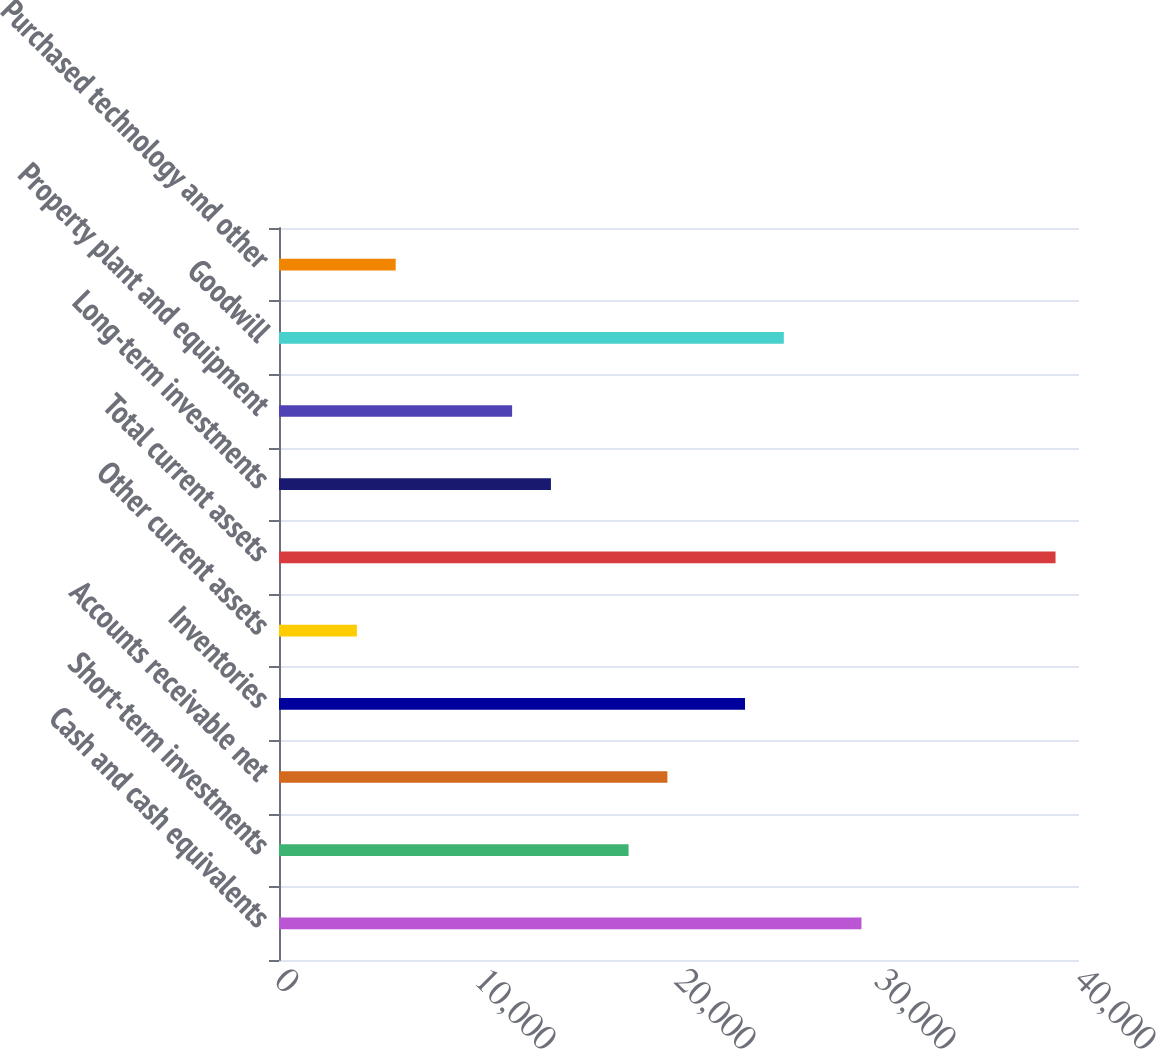Convert chart. <chart><loc_0><loc_0><loc_500><loc_500><bar_chart><fcel>Cash and cash equivalents<fcel>Short-term investments<fcel>Accounts receivable net<fcel>Inventories<fcel>Other current assets<fcel>Total current assets<fcel>Long-term investments<fcel>Property plant and equipment<fcel>Goodwill<fcel>Purchased technology and other<nl><fcel>29123<fcel>17478.2<fcel>19419<fcel>23300.6<fcel>3892.6<fcel>38827<fcel>13596.6<fcel>11655.8<fcel>25241.4<fcel>5833.4<nl></chart> 